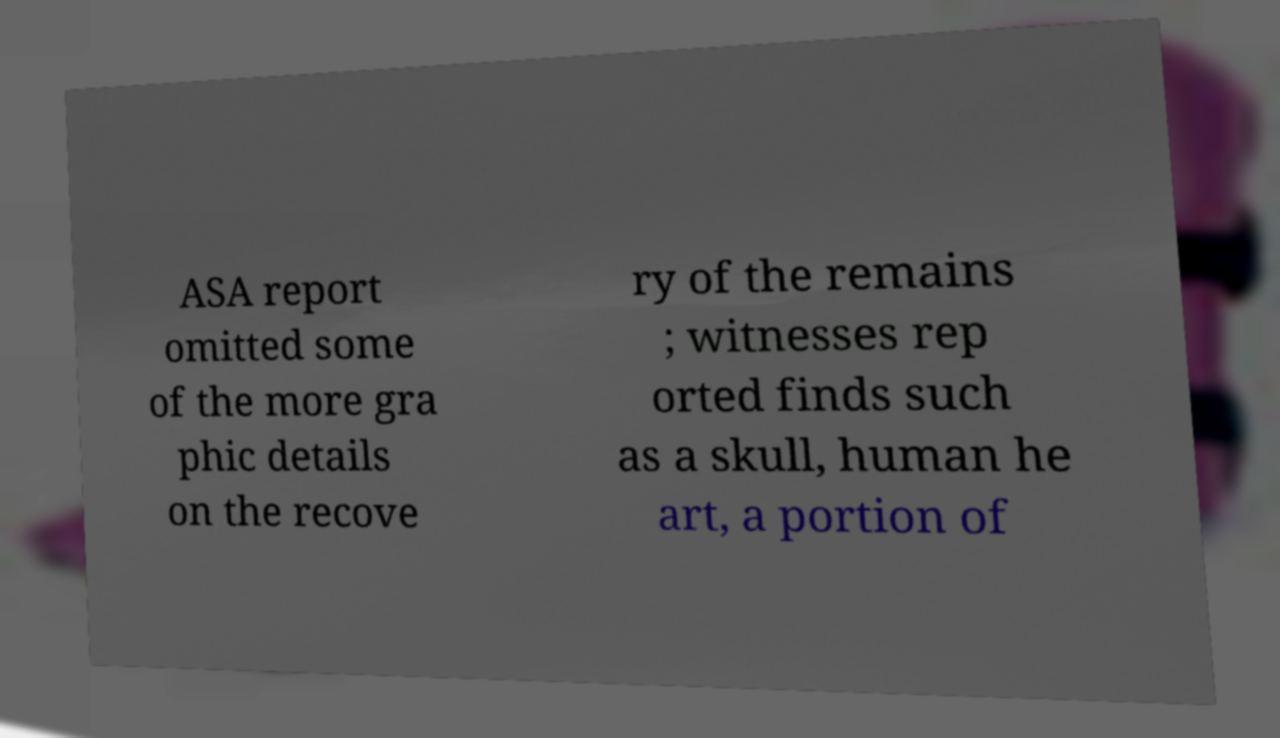There's text embedded in this image that I need extracted. Can you transcribe it verbatim? ASA report omitted some of the more gra phic details on the recove ry of the remains ; witnesses rep orted finds such as a skull, human he art, a portion of 